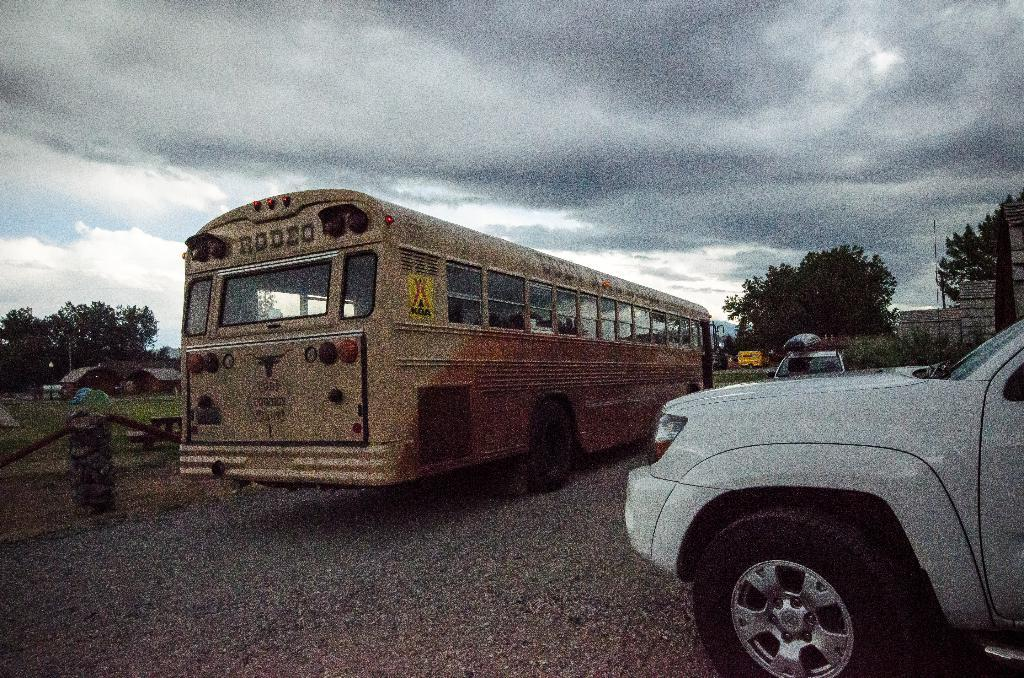<image>
Provide a brief description of the given image. A school bus from Cody Cowboy Stages is parked on the side of a road. 